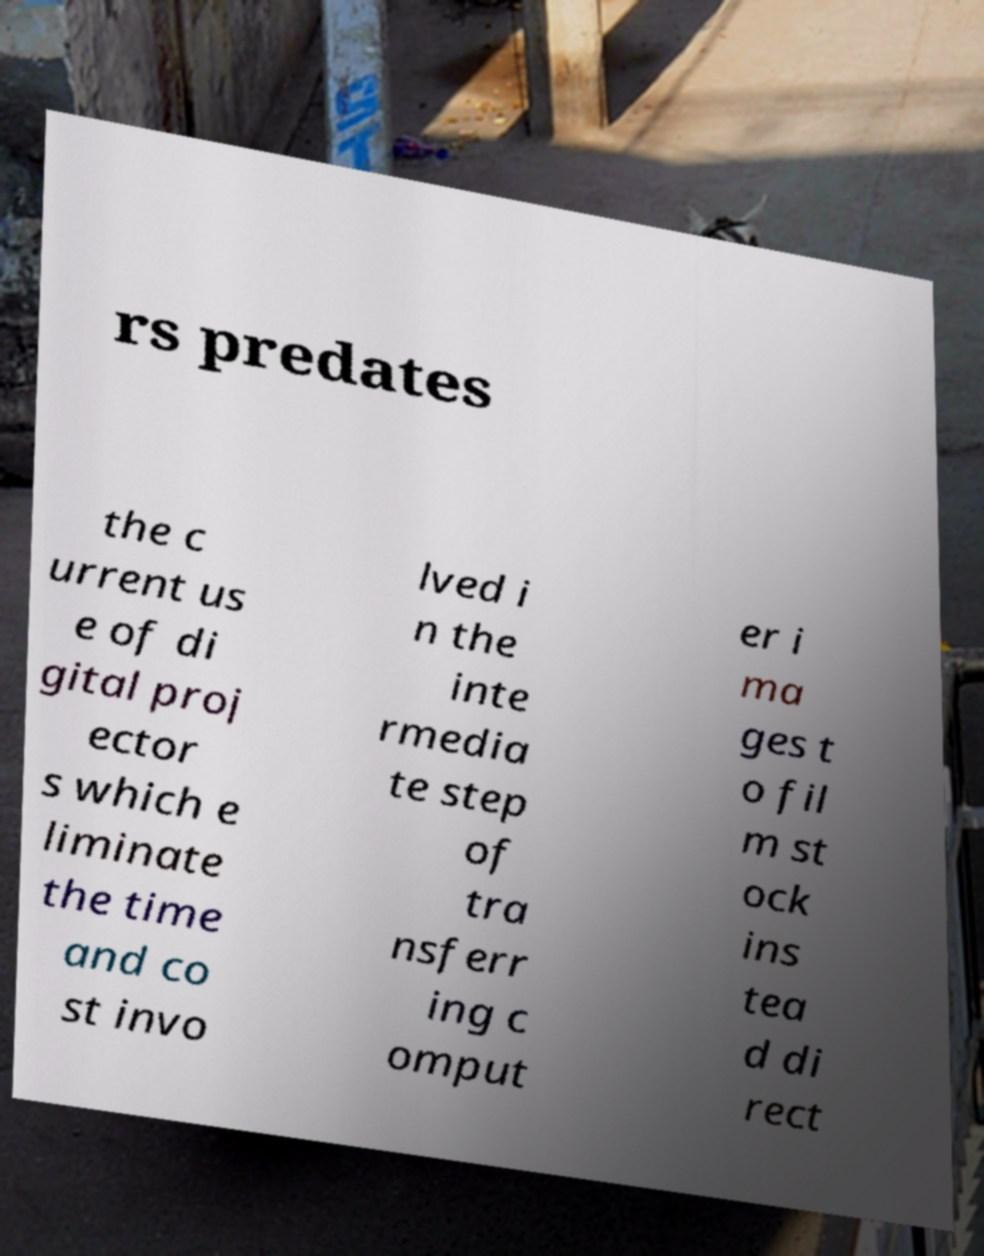Please read and relay the text visible in this image. What does it say? rs predates the c urrent us e of di gital proj ector s which e liminate the time and co st invo lved i n the inte rmedia te step of tra nsferr ing c omput er i ma ges t o fil m st ock ins tea d di rect 